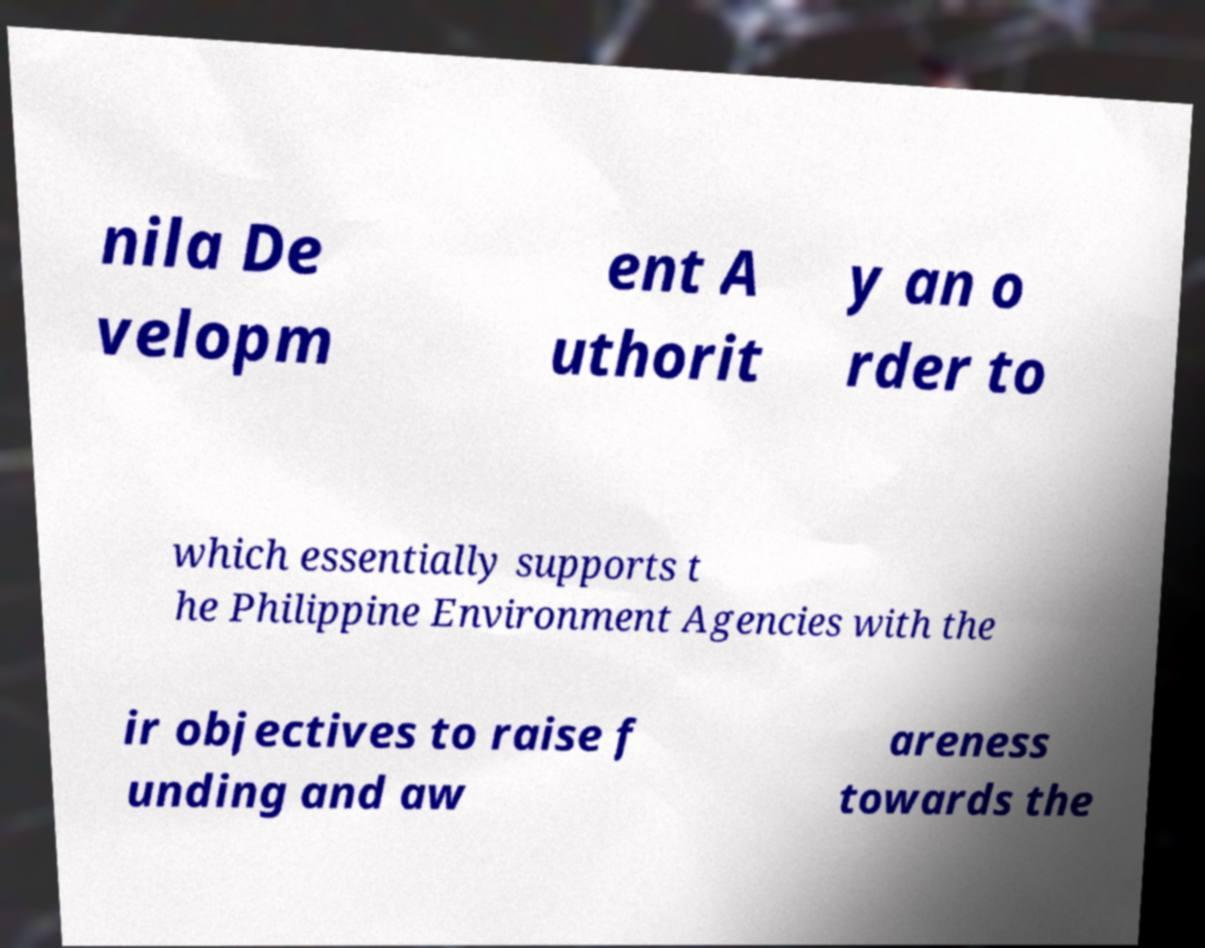Could you extract and type out the text from this image? nila De velopm ent A uthorit y an o rder to which essentially supports t he Philippine Environment Agencies with the ir objectives to raise f unding and aw areness towards the 